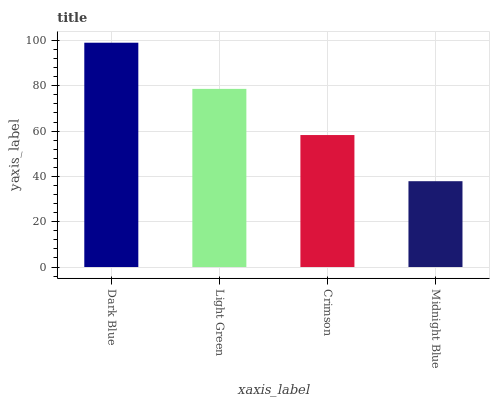Is Midnight Blue the minimum?
Answer yes or no. Yes. Is Dark Blue the maximum?
Answer yes or no. Yes. Is Light Green the minimum?
Answer yes or no. No. Is Light Green the maximum?
Answer yes or no. No. Is Dark Blue greater than Light Green?
Answer yes or no. Yes. Is Light Green less than Dark Blue?
Answer yes or no. Yes. Is Light Green greater than Dark Blue?
Answer yes or no. No. Is Dark Blue less than Light Green?
Answer yes or no. No. Is Light Green the high median?
Answer yes or no. Yes. Is Crimson the low median?
Answer yes or no. Yes. Is Crimson the high median?
Answer yes or no. No. Is Dark Blue the low median?
Answer yes or no. No. 